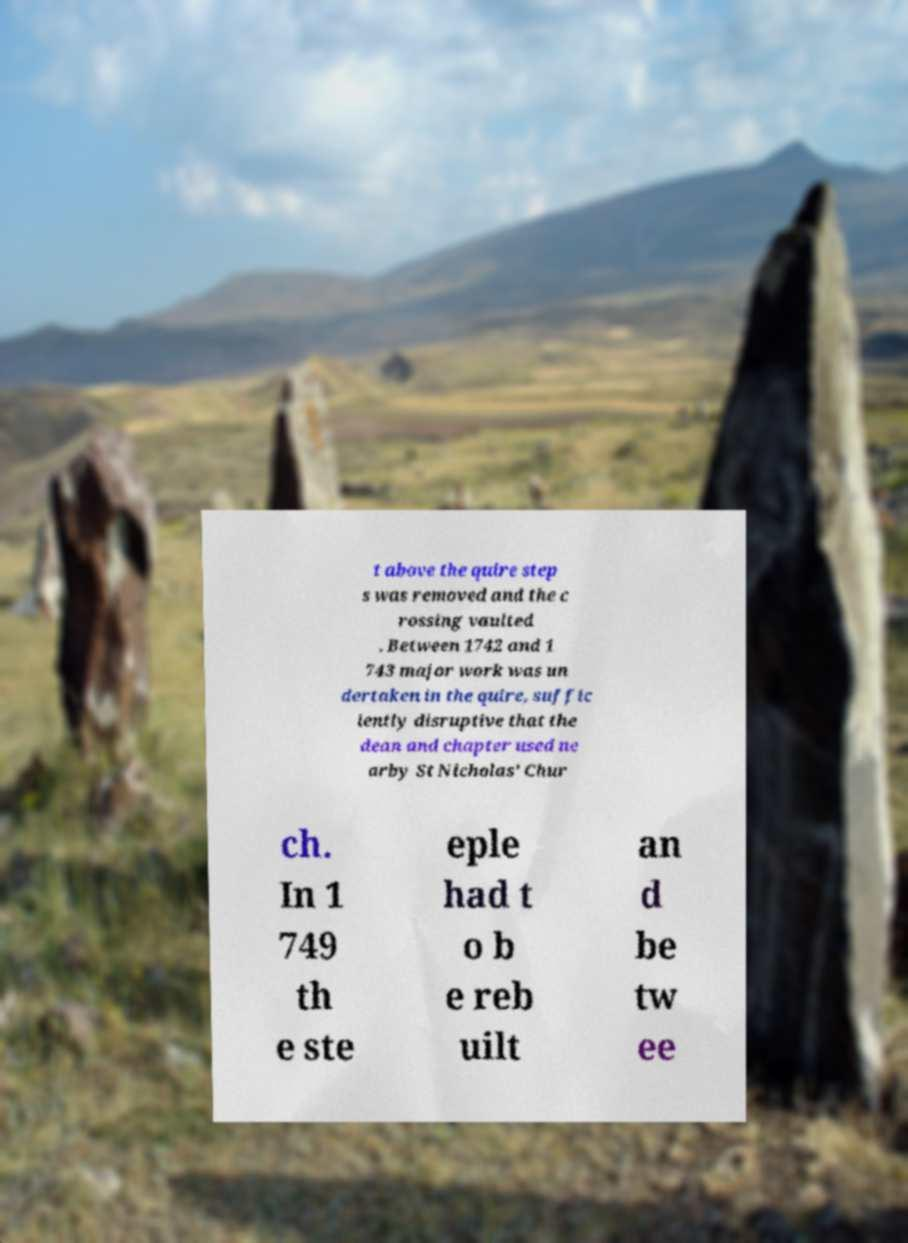Could you assist in decoding the text presented in this image and type it out clearly? t above the quire step s was removed and the c rossing vaulted . Between 1742 and 1 743 major work was un dertaken in the quire, suffic iently disruptive that the dean and chapter used ne arby St Nicholas' Chur ch. In 1 749 th e ste eple had t o b e reb uilt an d be tw ee 